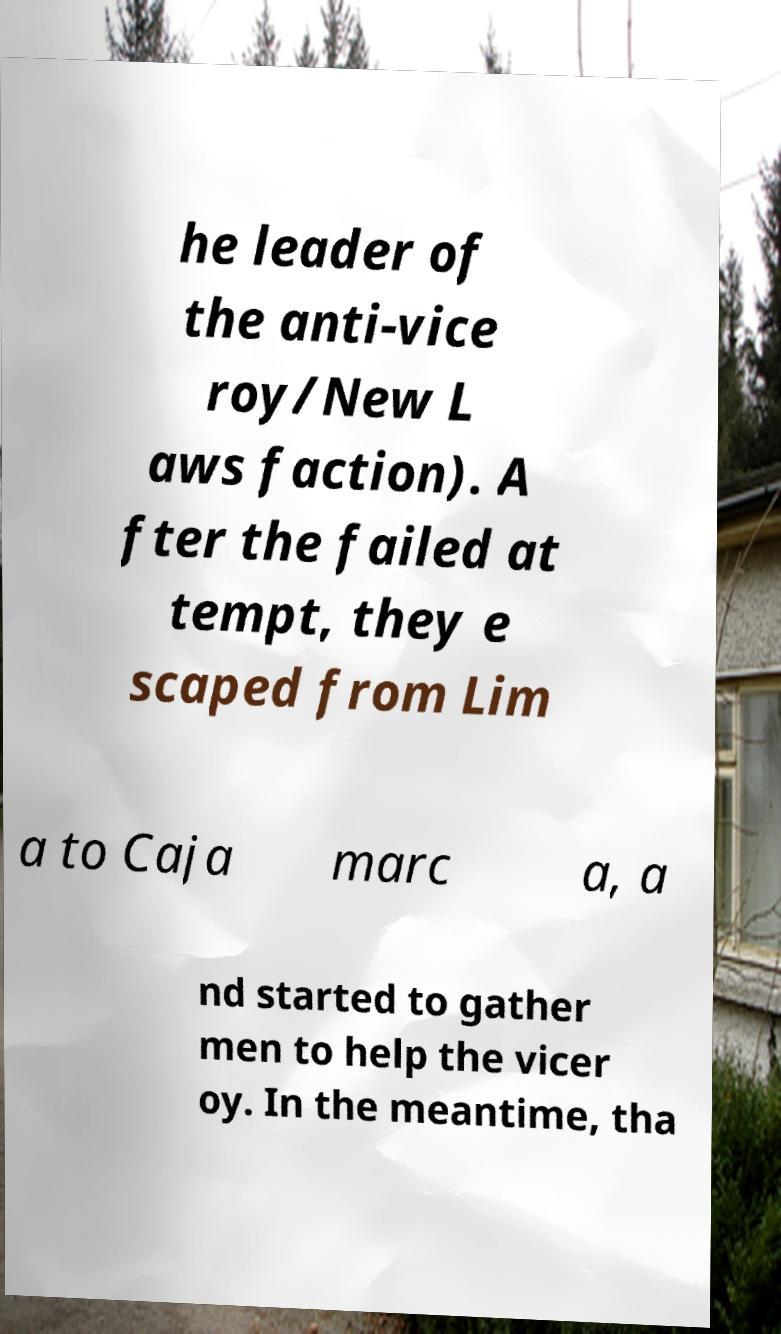Can you accurately transcribe the text from the provided image for me? he leader of the anti-vice roy/New L aws faction). A fter the failed at tempt, they e scaped from Lim a to Caja marc a, a nd started to gather men to help the vicer oy. In the meantime, tha 